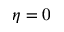<formula> <loc_0><loc_0><loc_500><loc_500>\eta = 0</formula> 